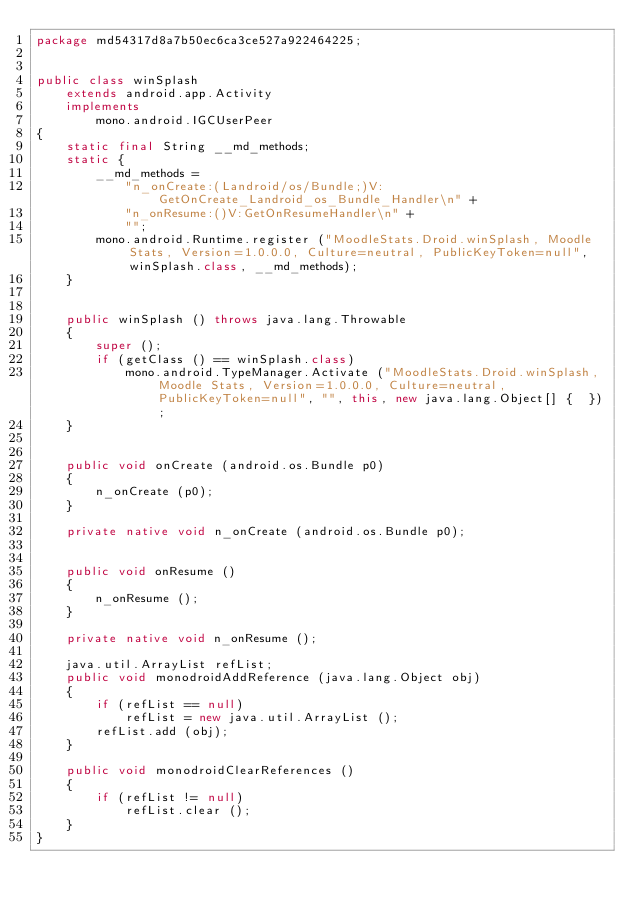Convert code to text. <code><loc_0><loc_0><loc_500><loc_500><_Java_>package md54317d8a7b50ec6ca3ce527a922464225;


public class winSplash
	extends android.app.Activity
	implements
		mono.android.IGCUserPeer
{
	static final String __md_methods;
	static {
		__md_methods = 
			"n_onCreate:(Landroid/os/Bundle;)V:GetOnCreate_Landroid_os_Bundle_Handler\n" +
			"n_onResume:()V:GetOnResumeHandler\n" +
			"";
		mono.android.Runtime.register ("MoodleStats.Droid.winSplash, Moodle Stats, Version=1.0.0.0, Culture=neutral, PublicKeyToken=null", winSplash.class, __md_methods);
	}


	public winSplash () throws java.lang.Throwable
	{
		super ();
		if (getClass () == winSplash.class)
			mono.android.TypeManager.Activate ("MoodleStats.Droid.winSplash, Moodle Stats, Version=1.0.0.0, Culture=neutral, PublicKeyToken=null", "", this, new java.lang.Object[] {  });
	}


	public void onCreate (android.os.Bundle p0)
	{
		n_onCreate (p0);
	}

	private native void n_onCreate (android.os.Bundle p0);


	public void onResume ()
	{
		n_onResume ();
	}

	private native void n_onResume ();

	java.util.ArrayList refList;
	public void monodroidAddReference (java.lang.Object obj)
	{
		if (refList == null)
			refList = new java.util.ArrayList ();
		refList.add (obj);
	}

	public void monodroidClearReferences ()
	{
		if (refList != null)
			refList.clear ();
	}
}
</code> 